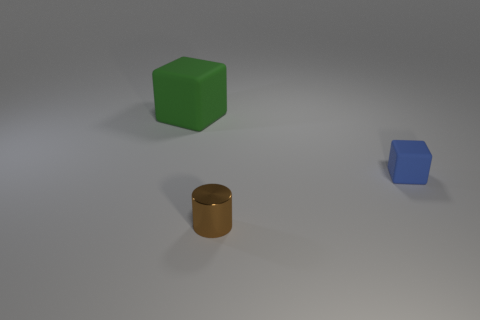Add 3 tiny cyan things. How many objects exist? 6 Subtract all cylinders. How many objects are left? 2 Add 1 cylinders. How many cylinders are left? 2 Add 1 big green blocks. How many big green blocks exist? 2 Subtract 1 brown cylinders. How many objects are left? 2 Subtract all tiny red metal cylinders. Subtract all tiny brown metallic cylinders. How many objects are left? 2 